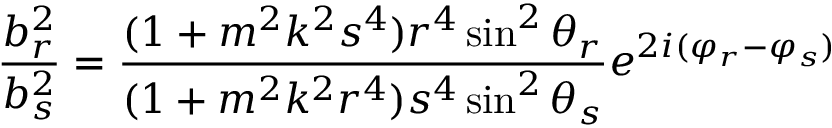<formula> <loc_0><loc_0><loc_500><loc_500>\frac { b _ { r } ^ { 2 } } { b _ { s } ^ { 2 } } = \frac { ( 1 + m ^ { 2 } k ^ { 2 } s ^ { 4 } ) r ^ { 4 } \sin ^ { 2 } \theta _ { r } } { ( 1 + m ^ { 2 } k ^ { 2 } r ^ { 4 } ) s ^ { 4 } \sin ^ { 2 } \theta _ { s } } e ^ { 2 i ( \varphi _ { r } - \varphi _ { s } ) }</formula> 